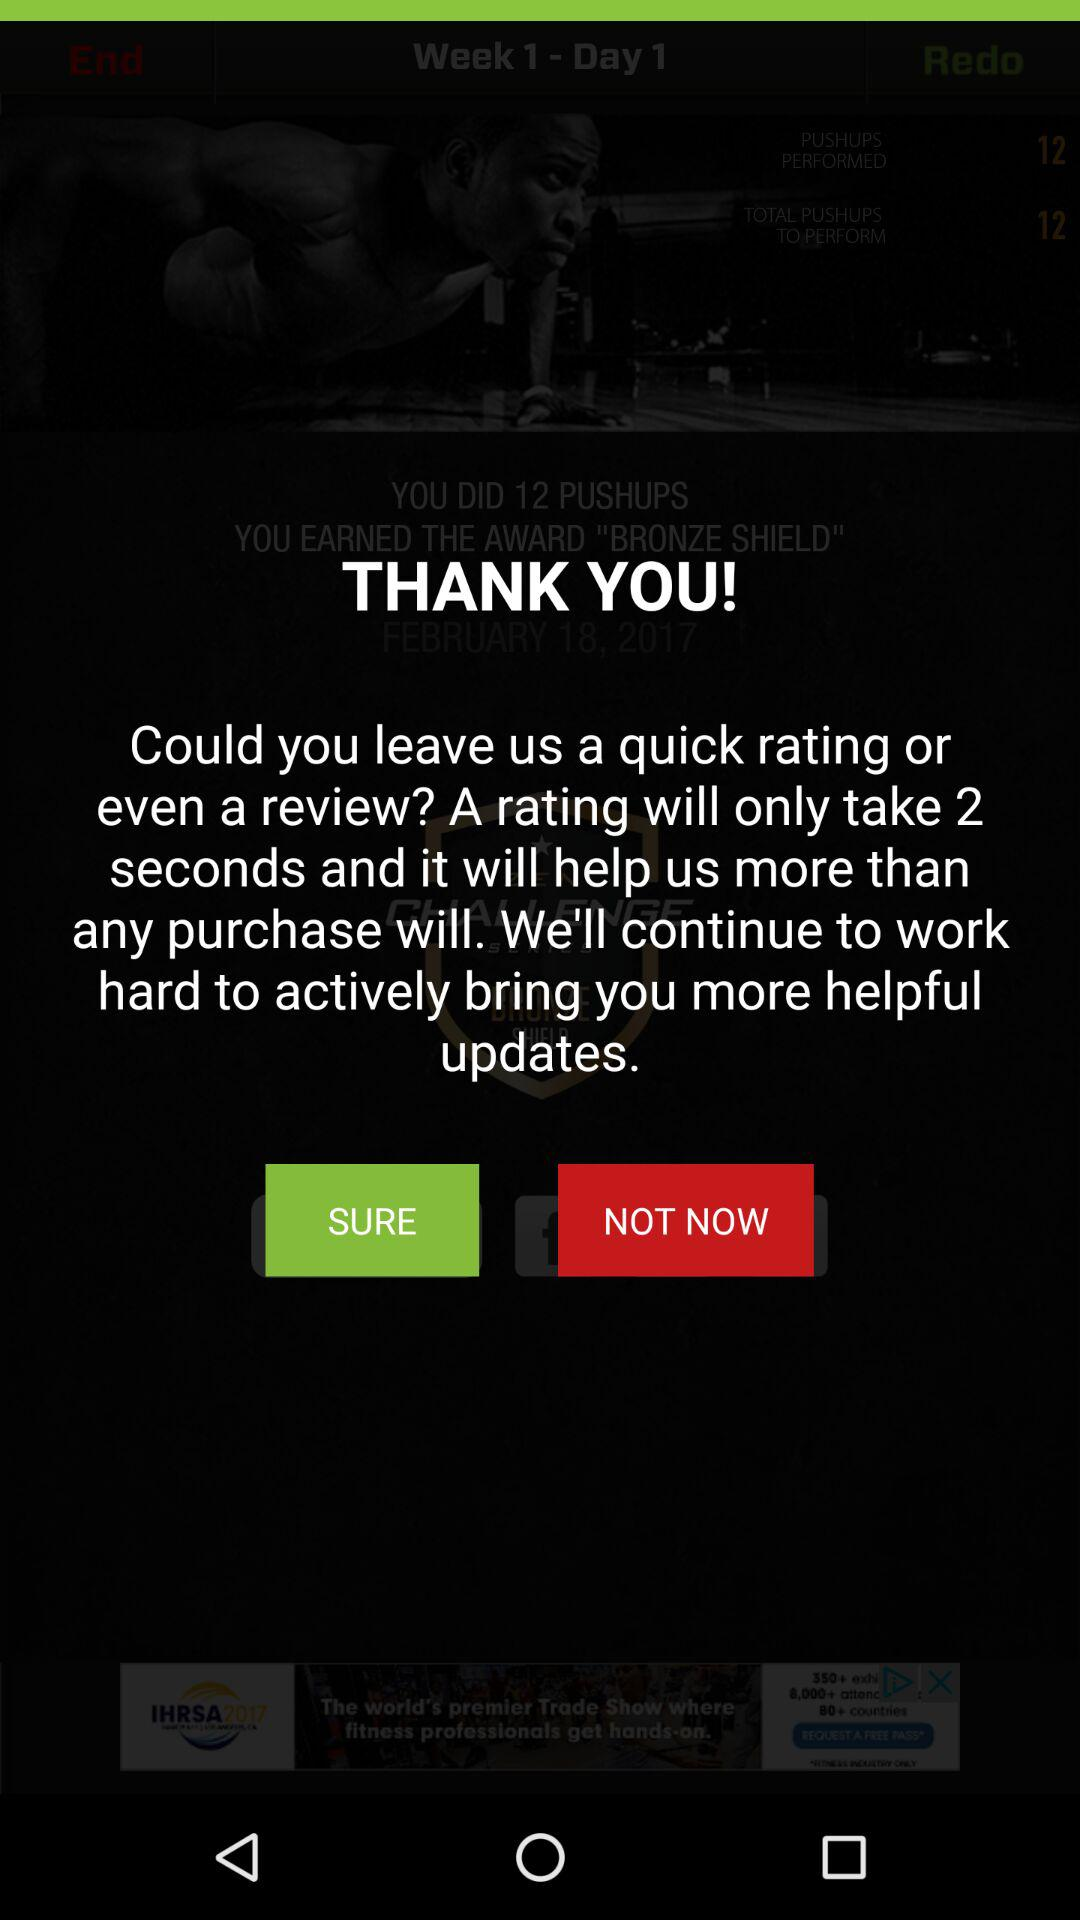How many seconds would it take to rate the app?
Answer the question using a single word or phrase. 2 